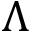Convert formula to latex. <formula><loc_0><loc_0><loc_500><loc_500>\Lambda</formula> 